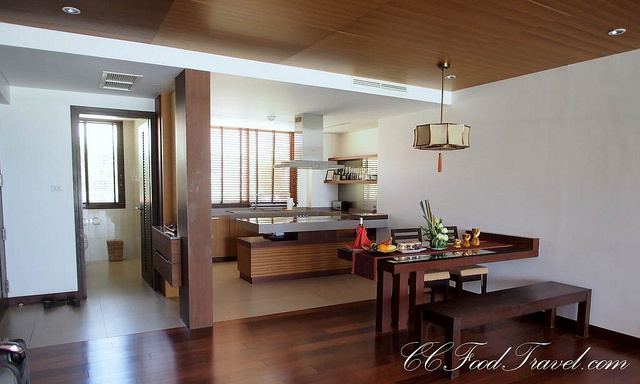Describe the objects in this image and their specific colors. I can see bench in black, maroon, gray, and darkgray tones, dining table in black, maroon, gray, and darkgray tones, chair in black, tan, and gray tones, potted plant in black, darkgray, gray, and darkgreen tones, and chair in black, maroon, darkgray, and gray tones in this image. 